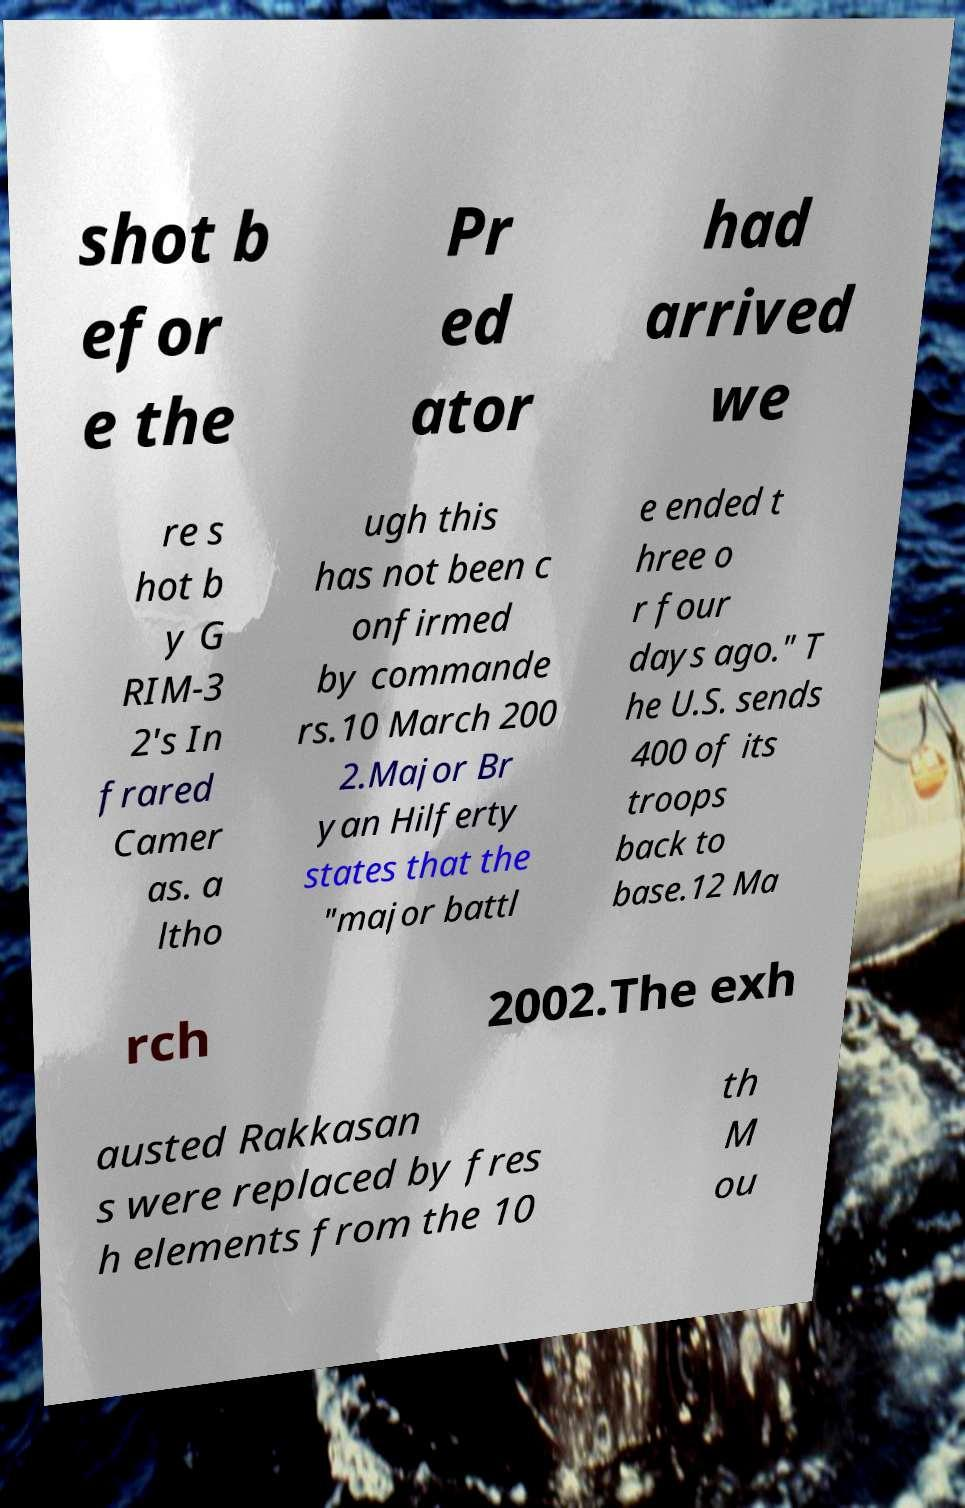Can you read and provide the text displayed in the image?This photo seems to have some interesting text. Can you extract and type it out for me? shot b efor e the Pr ed ator had arrived we re s hot b y G RIM-3 2's In frared Camer as. a ltho ugh this has not been c onfirmed by commande rs.10 March 200 2.Major Br yan Hilferty states that the "major battl e ended t hree o r four days ago." T he U.S. sends 400 of its troops back to base.12 Ma rch 2002.The exh austed Rakkasan s were replaced by fres h elements from the 10 th M ou 